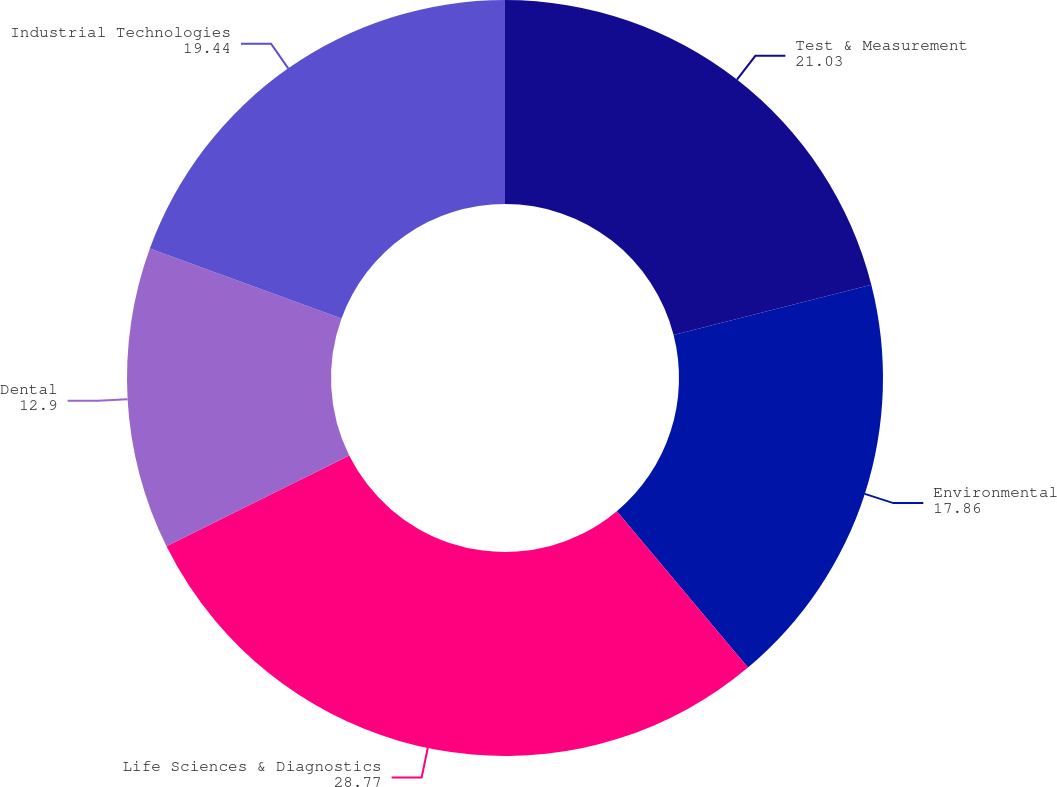Convert chart to OTSL. <chart><loc_0><loc_0><loc_500><loc_500><pie_chart><fcel>Test & Measurement<fcel>Environmental<fcel>Life Sciences & Diagnostics<fcel>Dental<fcel>Industrial Technologies<nl><fcel>21.03%<fcel>17.86%<fcel>28.77%<fcel>12.9%<fcel>19.44%<nl></chart> 